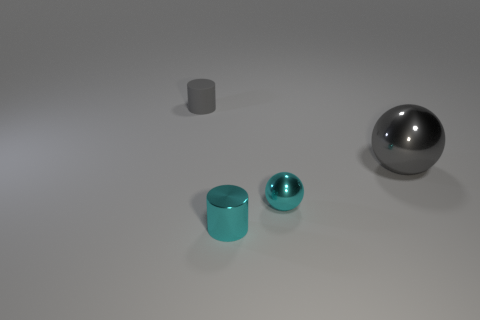Add 2 red shiny blocks. How many objects exist? 6 Add 2 small cylinders. How many small cylinders are left? 4 Add 1 gray rubber cylinders. How many gray rubber cylinders exist? 2 Subtract 0 blue blocks. How many objects are left? 4 Subtract all tiny blue metallic cubes. Subtract all big gray balls. How many objects are left? 3 